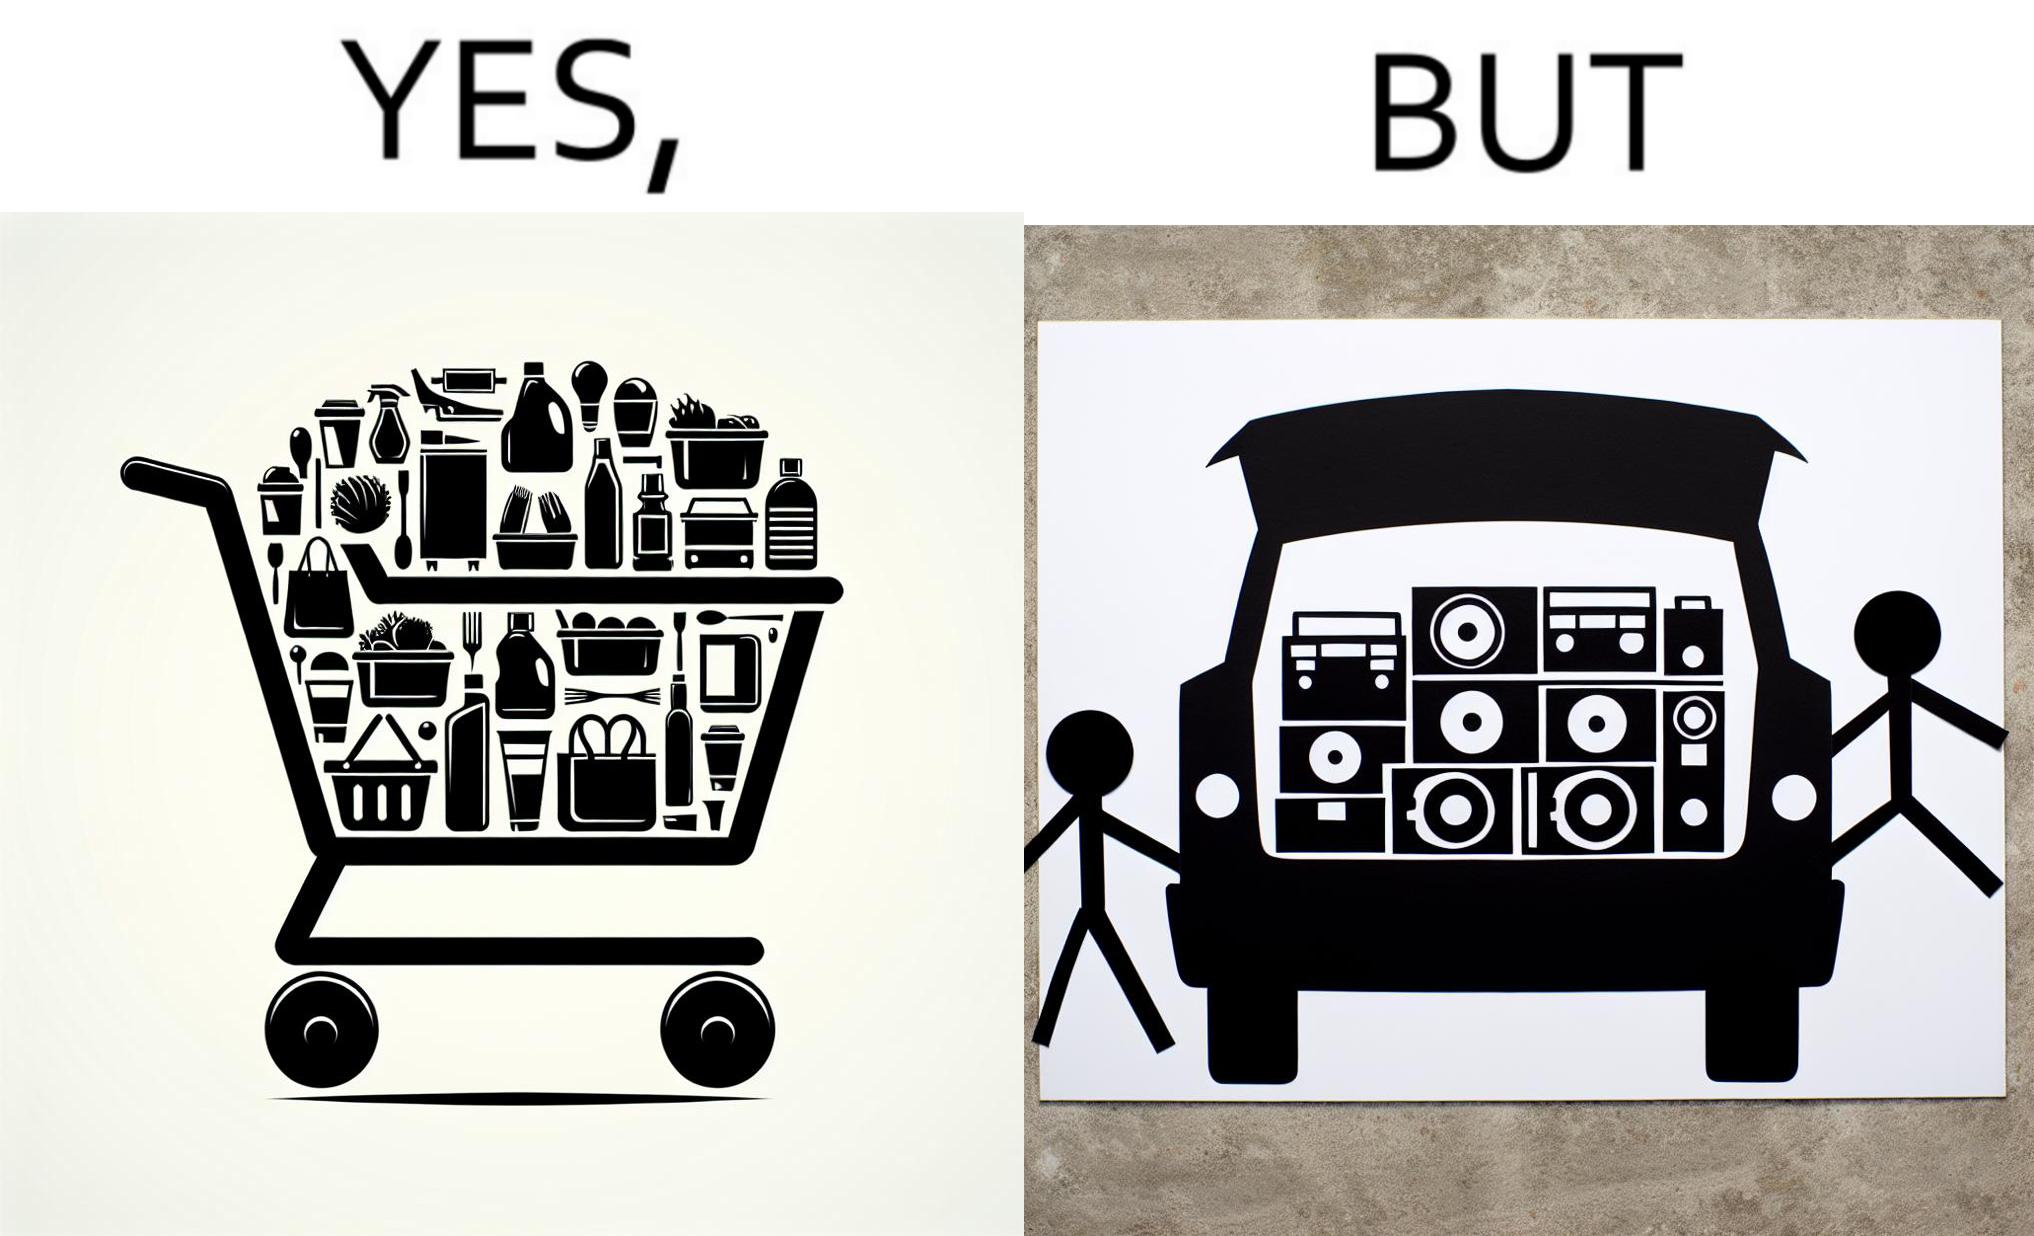What is shown in the left half versus the right half of this image? In the left part of the image: a shopping cart full of items In the right part of the image: a black car with its trunk lid open and some boxes, probably speakers, kept in the trunk 